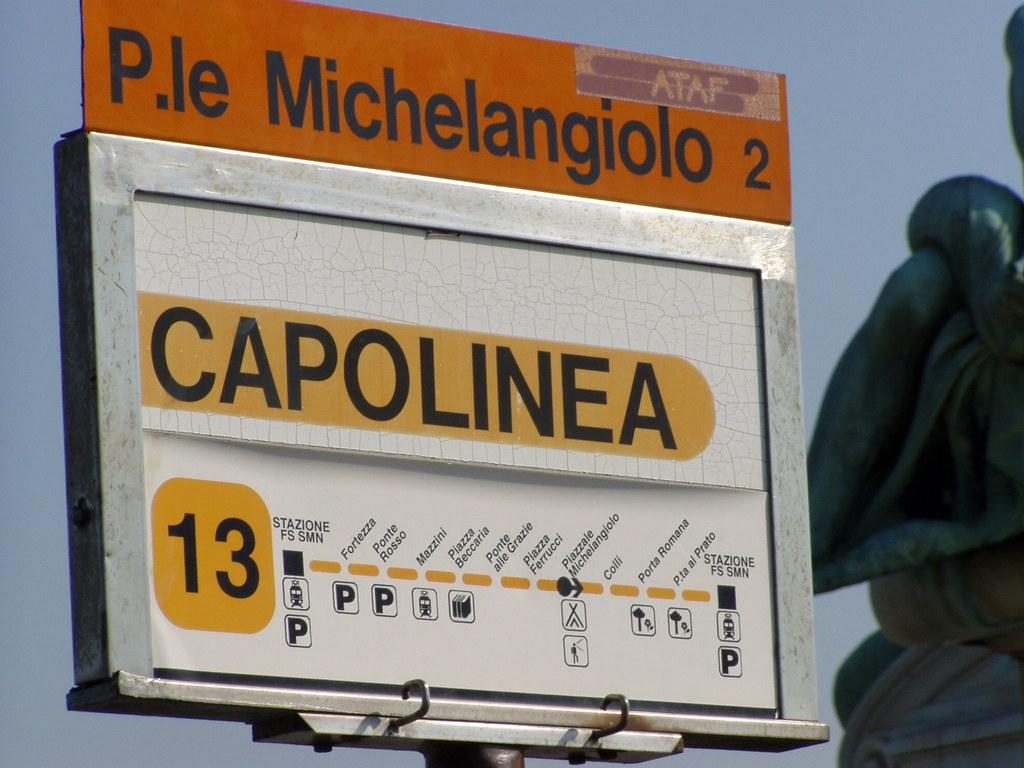<image>
Write a terse but informative summary of the picture. A sign detailing mass transit stops that says Capolinea. 